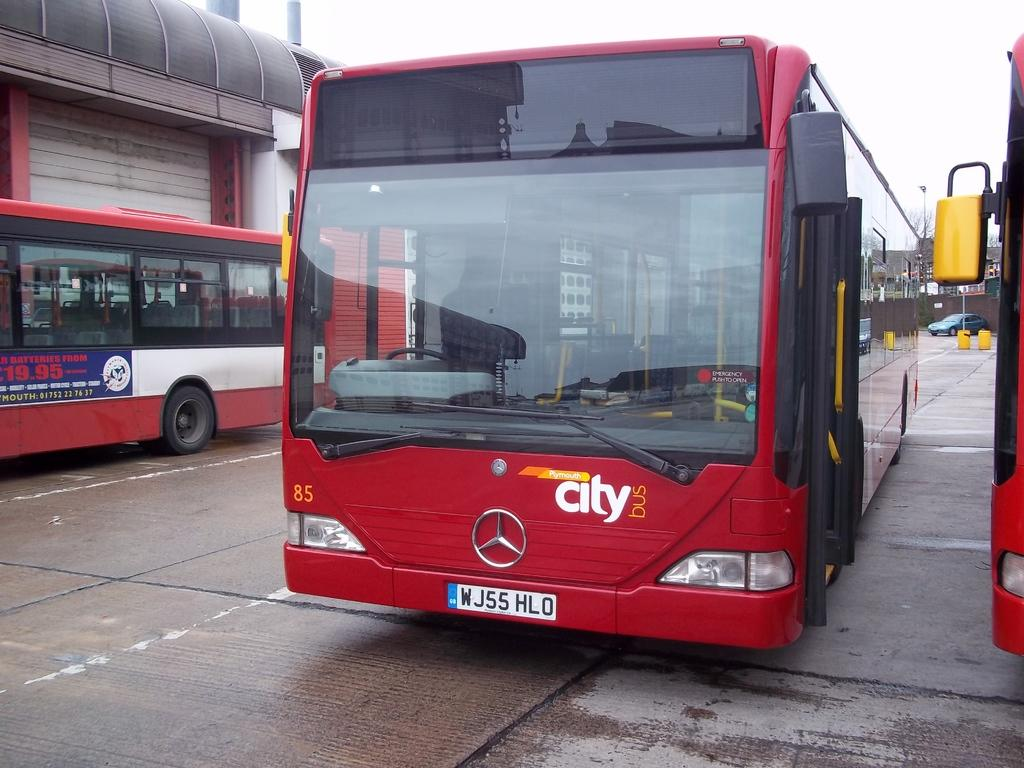<image>
Relay a brief, clear account of the picture shown. the red city bus is sitting with other buses like it 